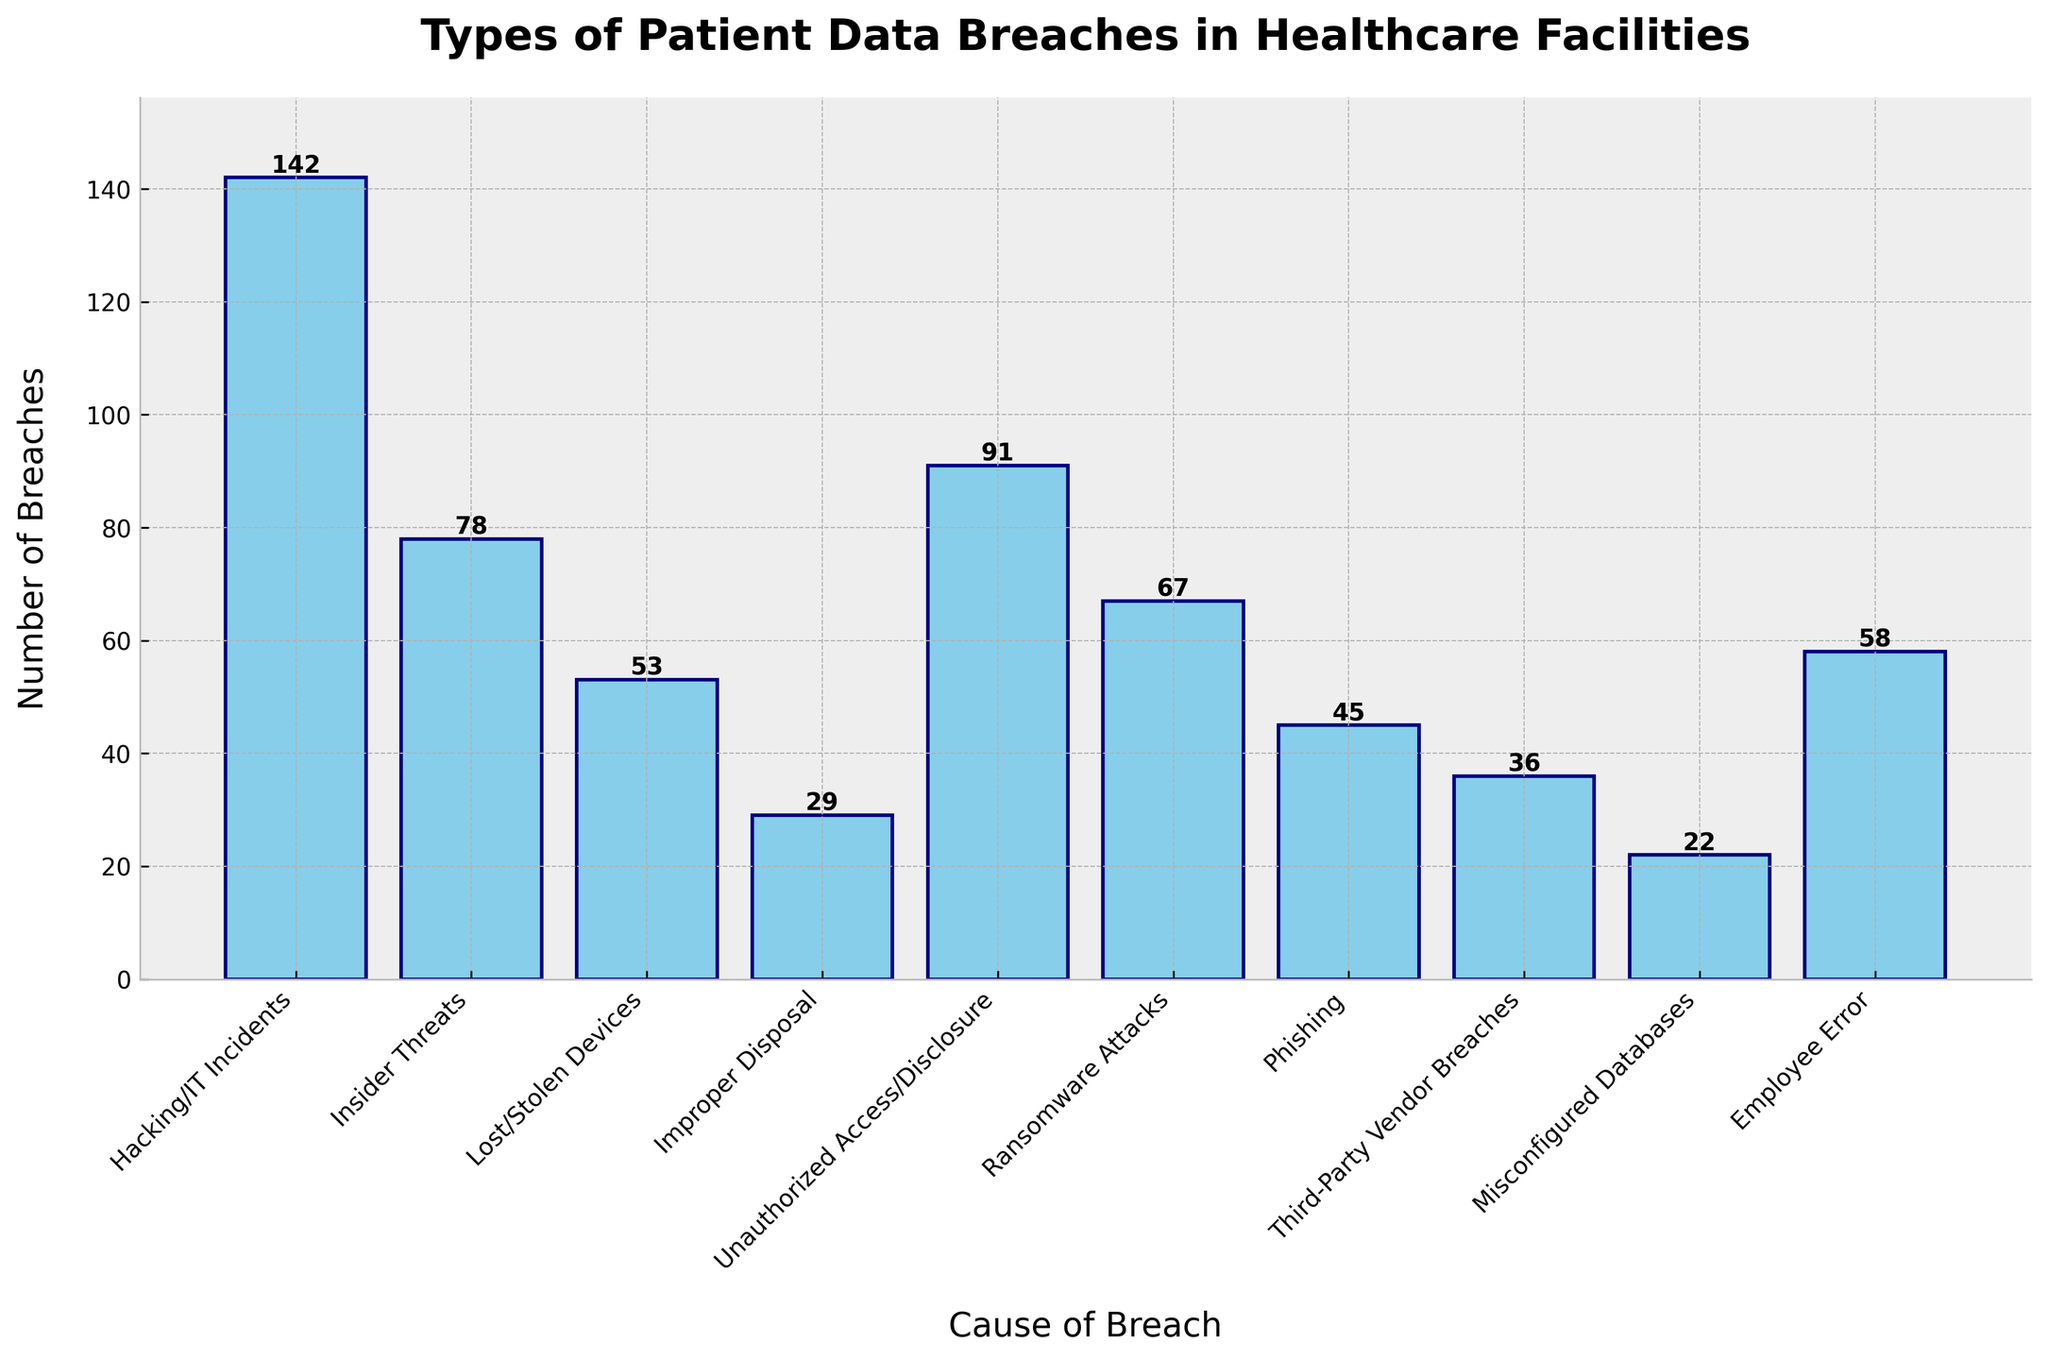Which cause of breach has the highest number of incidents? The highest bar represents the cause with the most breaches. The bar for "Hacking/IT Incidents" is the tallest.
Answer: Hacking/IT Incidents Which cause of breach has the lowest number of incidents? The shortest bar indicates the cause with the fewest breaches. The bar for "Misconfigured Databases" is the shortest.
Answer: Misconfigured Databases How many more breaches are caused by Unauthorized Access/Disclosure compared to Phishing? The number of breaches for Unauthorized Access/Disclosure is 91 and for Phishing is 45. The difference is 91 - 45.
Answer: 46 What is the total number of breaches from Insider Threats and Employee Error combined? The number of breaches for Insider Threats is 78 and for Employee Error is 58. Adding them together gives 78 + 58.
Answer: 136 Rank the first three causes of breaches in descending order based on the number of breaches. The highest number of breaches is 142 for Hacking/IT Incidents, followed by 91 for Unauthorized Access/Disclosure, and 78 for Insider Threats.
Answer: Hacking/IT Incidents, Unauthorized Access/Disclosure, Insider Threats Are there more breaches caused by Lost/Stolen Devices or Ransomware Attacks? The bar for Lost/Stolen Devices shows 53 breaches, and the bar for Ransomware Attacks shows 67 breaches.
Answer: Ransomware Attacks What’s the average number of breaches for the top three causes? The top three causes are Hacking/IT Incidents (142), Unauthorized Access/Disclosure (91), and Insider Threats (78). Their sum is 142 + 91 + 78 = 311. The average is 311 / 3.
Answer: 103.67 Which breach causes lie below the average number of breaches for all given causes? First, calculate the average number of breaches by summing all the breaches and dividing them by the number of causes: (142 + 78 + 53 + 29 + 91 + 67 + 45 + 36 + 22 + 58) / 10 = 621 / 10 = 62.1. Comparing each cause's breaches to the average, those below are Lost/Stolen Devices (53), Improper Disposal (29), Phishing (45), Third-Party Vendor Breaches (36), Misconfigured Databases (22), and Employee Error (58).
Answer: Lost/Stolen Devices, Improper Disposal, Phishing, Third-Party Vendor Breaches, Misconfigured Databases, Employee Error Which two causes of breaches have an equal number of incidents? Observing the bars for matching lengths, none have the exact same height, indicating no two causes share the same number of breaches.
Answer: None How many breaches are there from phishing compared to unauthorized access/disclosure, and which is greater? The number of breaches from Phishing is 45 and from Unauthorized Access/Disclosure is 91. Comparing the two, 91 is greater than 45.
Answer: Unauthorized Access/Disclosure If all breaches related to technical issues (Hacking/IT Incidents, Ransomware Attacks, Phishing, Misconfigured Databases) are combined, what is the total? Sum the breaches for each of the technical issues: Hacking/IT Incidents is 142, Ransomware Attacks is 67, Phishing is 45, Misconfigured Databases is 22. The total is 142 + 67 + 45 + 22.
Answer: 276 